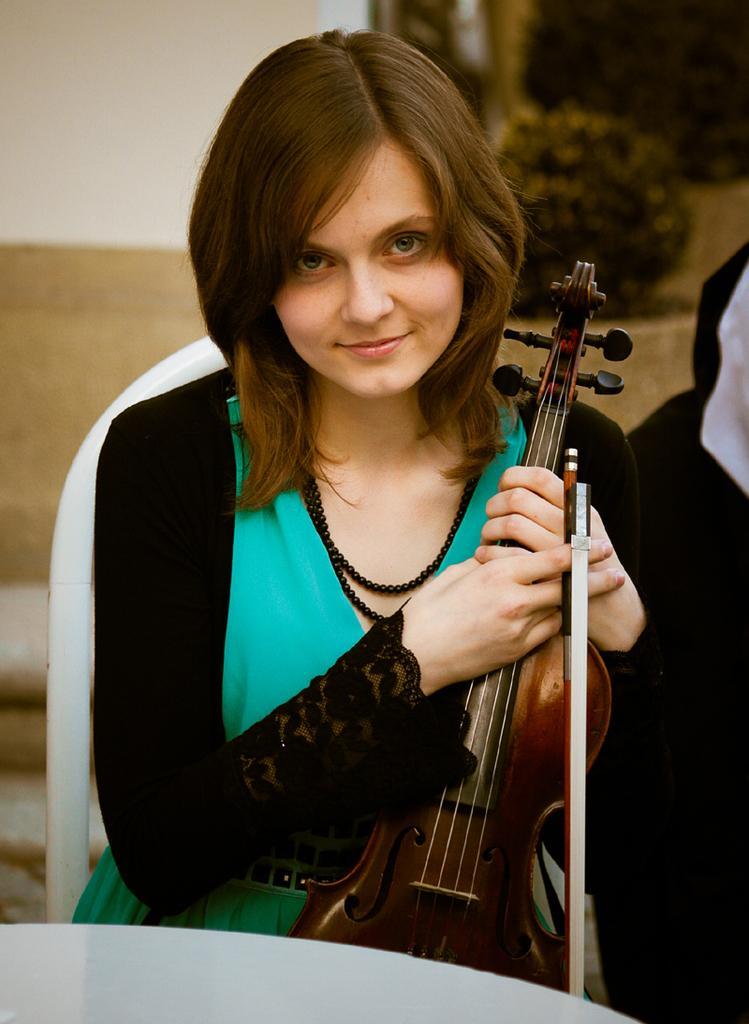Please provide a concise description of this image. In this image I can see a person smiling and holding the musical instrument. In the background there are trees. 